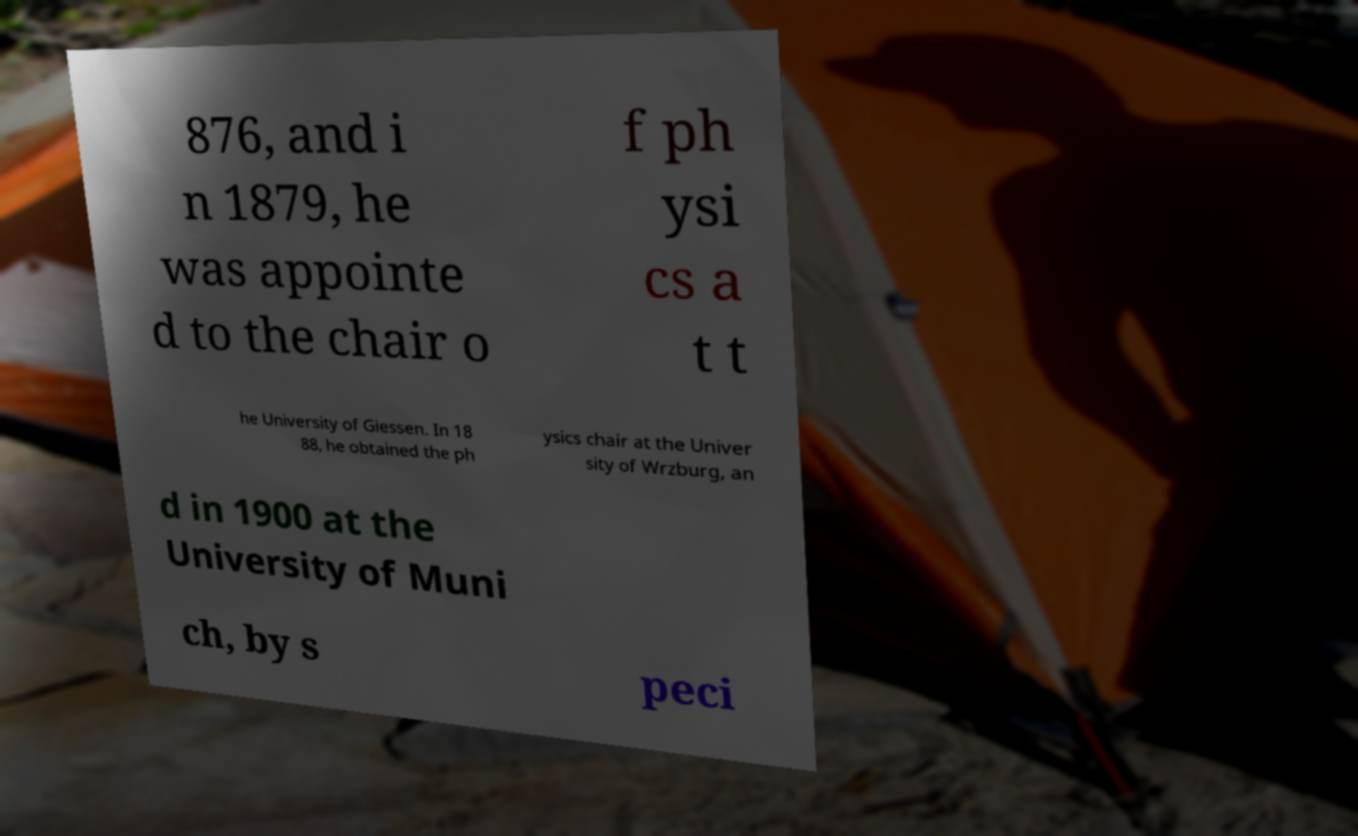What messages or text are displayed in this image? I need them in a readable, typed format. 876, and i n 1879, he was appointe d to the chair o f ph ysi cs a t t he University of Giessen. In 18 88, he obtained the ph ysics chair at the Univer sity of Wrzburg, an d in 1900 at the University of Muni ch, by s peci 